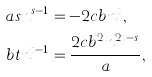<formula> <loc_0><loc_0><loc_500><loc_500>a s n ^ { s - 1 } & = - 2 c b n ^ { t } , \\ b t n ^ { t - 1 } & = \frac { { 2 c b ^ { 2 } n ^ { 2 t - s } } } { a } ,</formula> 